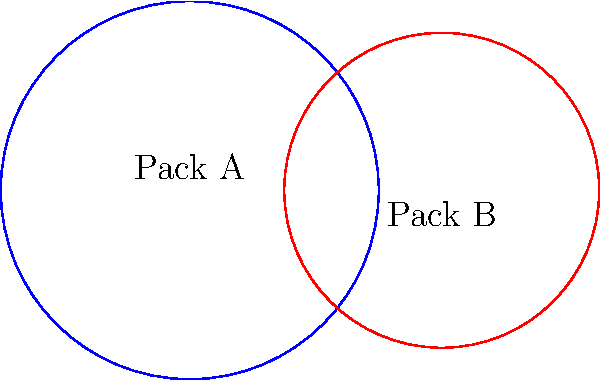Two rival wolf packs, Pack A and Pack B, have circular territories that overlap as shown. Pack A's territory has a radius of 3 km, while Pack B's territory has a radius of 2.5 km. The centers of their territories are 4 km apart. Which pack has a larger perimeter to defend, and by how much? To solve this problem, we need to calculate the perimeters of both territories and compare them:

1. Calculate the perimeter of Pack A's territory:
   $P_A = 2\pi r_A = 2\pi \cdot 3 = 6\pi$ km

2. Calculate the perimeter of Pack B's territory:
   $P_B = 2\pi r_B = 2\pi \cdot 2.5 = 5\pi$ km

3. Calculate the difference in perimeters:
   $\Delta P = P_A - P_B = 6\pi - 5\pi = \pi$ km

4. Convert $\pi$ km to a decimal approximation:
   $\pi \approx 3.14159$ km

Therefore, Pack A has a larger perimeter to defend, and the difference is approximately 3.14159 km.
Answer: Pack A; $\pi$ km ($\approx 3.14159$ km) 